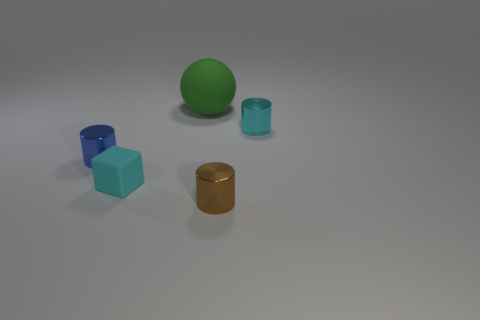Add 2 large cyan metal balls. How many objects exist? 7 Subtract 1 cylinders. How many cylinders are left? 2 Subtract all spheres. How many objects are left? 4 Subtract all cyan cylinders. How many cylinders are left? 2 Subtract all metallic cylinders. Subtract all tiny cyan blocks. How many objects are left? 1 Add 5 tiny cyan blocks. How many tiny cyan blocks are left? 6 Add 4 small red matte cylinders. How many small red matte cylinders exist? 4 Subtract 0 gray cylinders. How many objects are left? 5 Subtract all red cylinders. Subtract all red blocks. How many cylinders are left? 3 